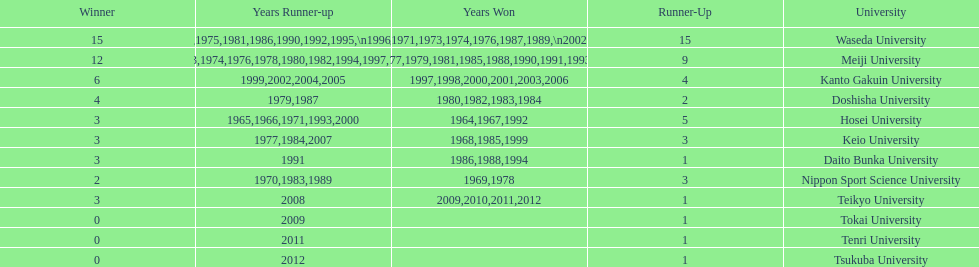How many championships does nippon sport science university have 2. 